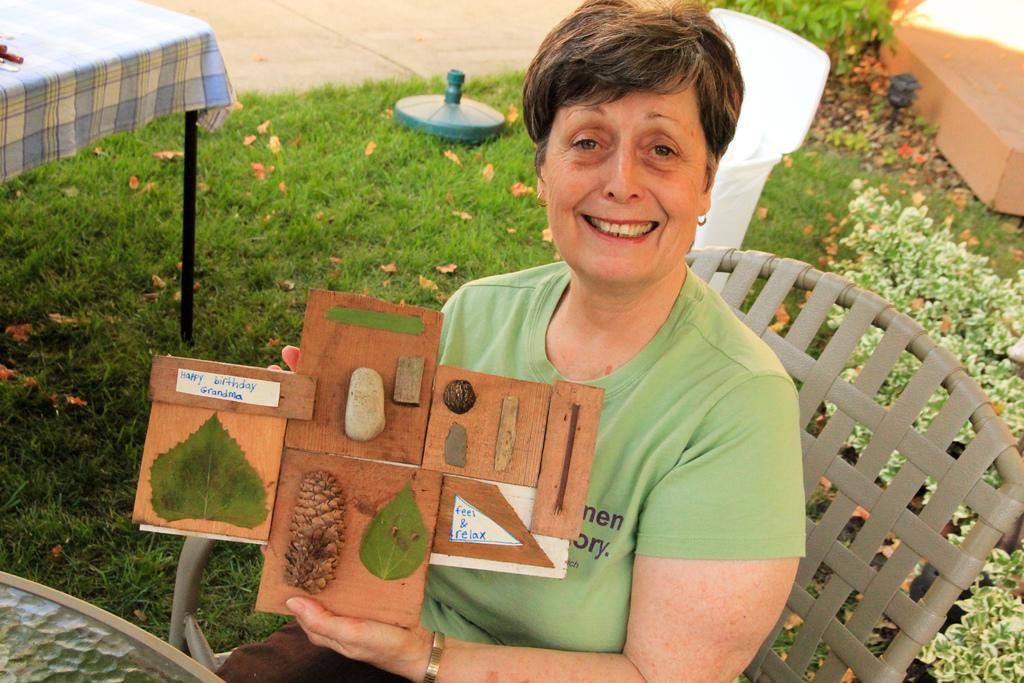Could you give a brief overview of what you see in this image? Woman is sitting on the chair and holding a wooden sheet. She wore a green color t-shirt, on the right side there are small plants. 